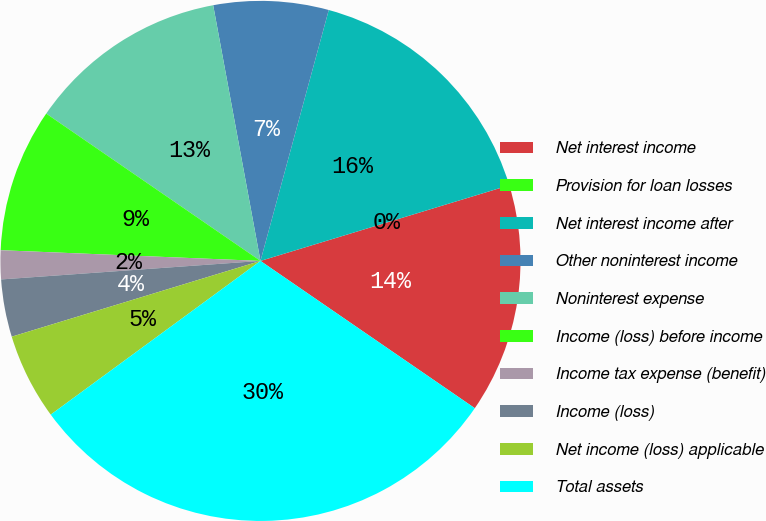Convert chart. <chart><loc_0><loc_0><loc_500><loc_500><pie_chart><fcel>Net interest income<fcel>Provision for loan losses<fcel>Net interest income after<fcel>Other noninterest income<fcel>Noninterest expense<fcel>Income (loss) before income<fcel>Income tax expense (benefit)<fcel>Income (loss)<fcel>Net income (loss) applicable<fcel>Total assets<nl><fcel>14.28%<fcel>0.0%<fcel>16.07%<fcel>7.14%<fcel>12.5%<fcel>8.93%<fcel>1.79%<fcel>3.57%<fcel>5.36%<fcel>30.35%<nl></chart> 